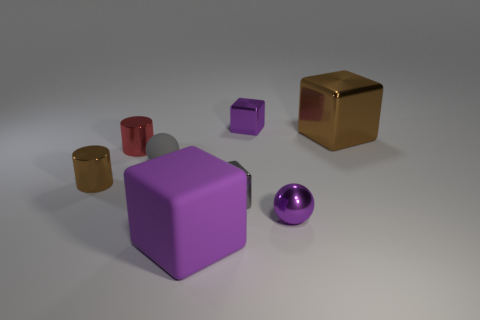Subtract all metal cubes. How many cubes are left? 1 Add 1 blue balls. How many objects exist? 9 Subtract all brown blocks. How many blocks are left? 3 Subtract all cylinders. How many objects are left? 6 Subtract 1 blocks. How many blocks are left? 3 Subtract all gray balls. Subtract all brown cylinders. How many balls are left? 1 Subtract all cyan blocks. How many gray balls are left? 1 Subtract all big matte cubes. Subtract all brown metallic cylinders. How many objects are left? 6 Add 2 brown blocks. How many brown blocks are left? 3 Add 3 green things. How many green things exist? 3 